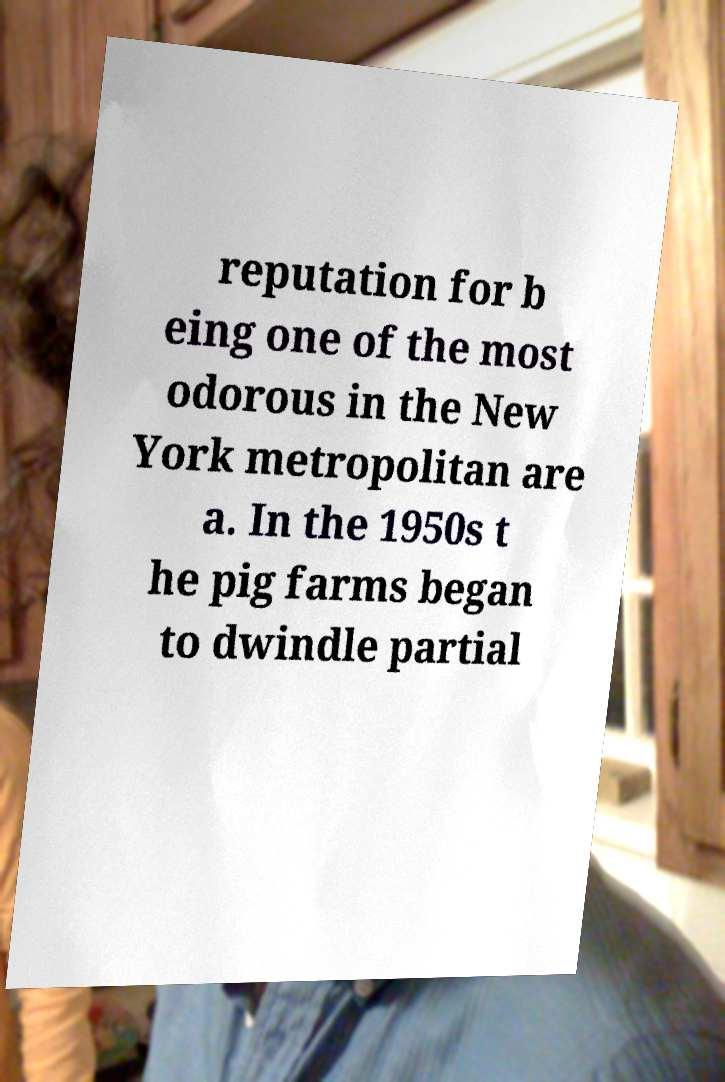What messages or text are displayed in this image? I need them in a readable, typed format. reputation for b eing one of the most odorous in the New York metropolitan are a. In the 1950s t he pig farms began to dwindle partial 